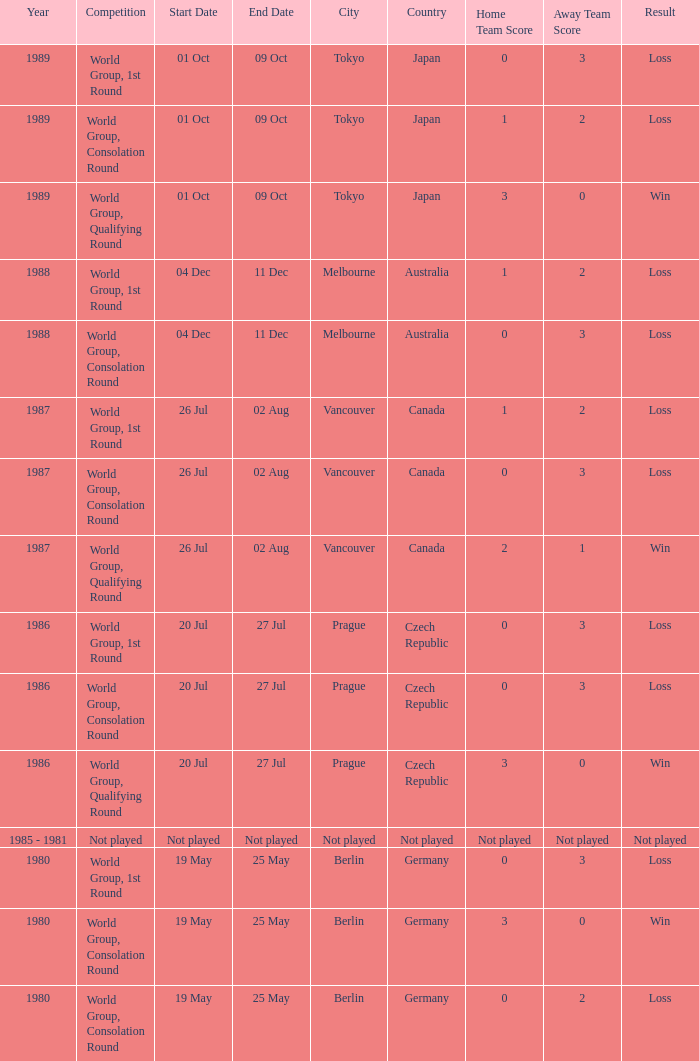What is the competition when the result is loss in berlin with a score of 0-3? World Group, 1st Round. 